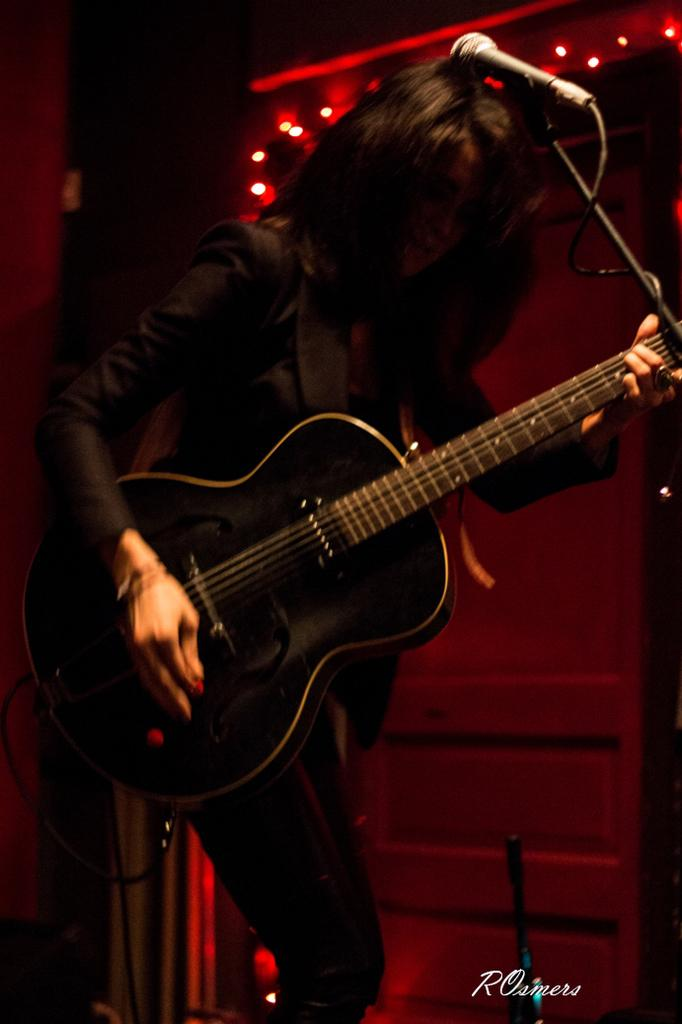Who is the main subject in the image? There is a woman in the image. What is the woman doing in the image? The woman is standing and playing a guitar. What object is in front of the woman? There is a microphone in front of the woman. What can be seen in the background of the image? The background of the image includes lighting. What type of vessel is being used to measure the distance between the woman and the microphone in the image? There is no vessel present in the image, and the concept of measuring distance is not applicable in this context. 